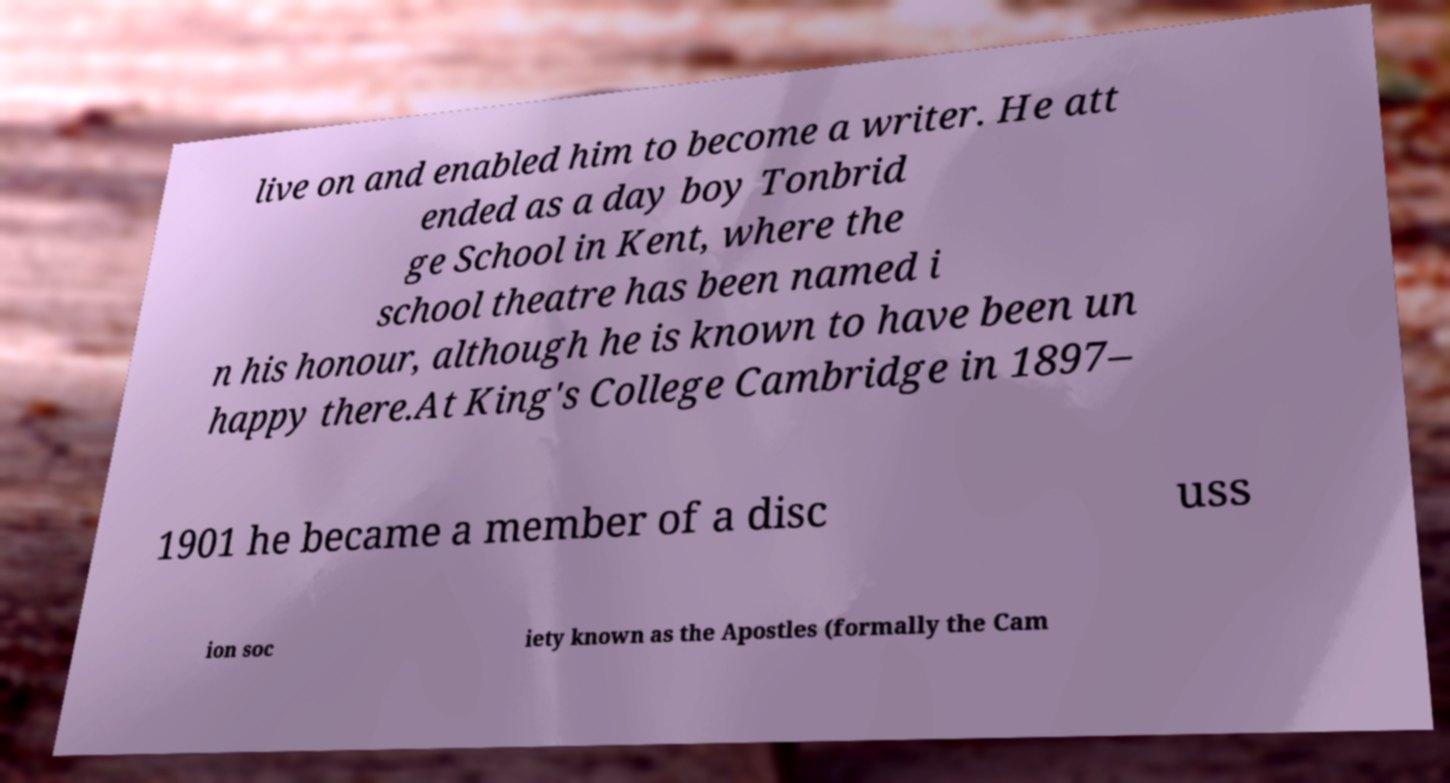Could you extract and type out the text from this image? live on and enabled him to become a writer. He att ended as a day boy Tonbrid ge School in Kent, where the school theatre has been named i n his honour, although he is known to have been un happy there.At King's College Cambridge in 1897– 1901 he became a member of a disc uss ion soc iety known as the Apostles (formally the Cam 